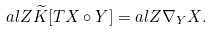Convert formula to latex. <formula><loc_0><loc_0><loc_500><loc_500>a l { Z } { \widetilde { K } [ T X \circ Y ] } = a l { Z } { { \nabla } _ { Y } X } .</formula> 